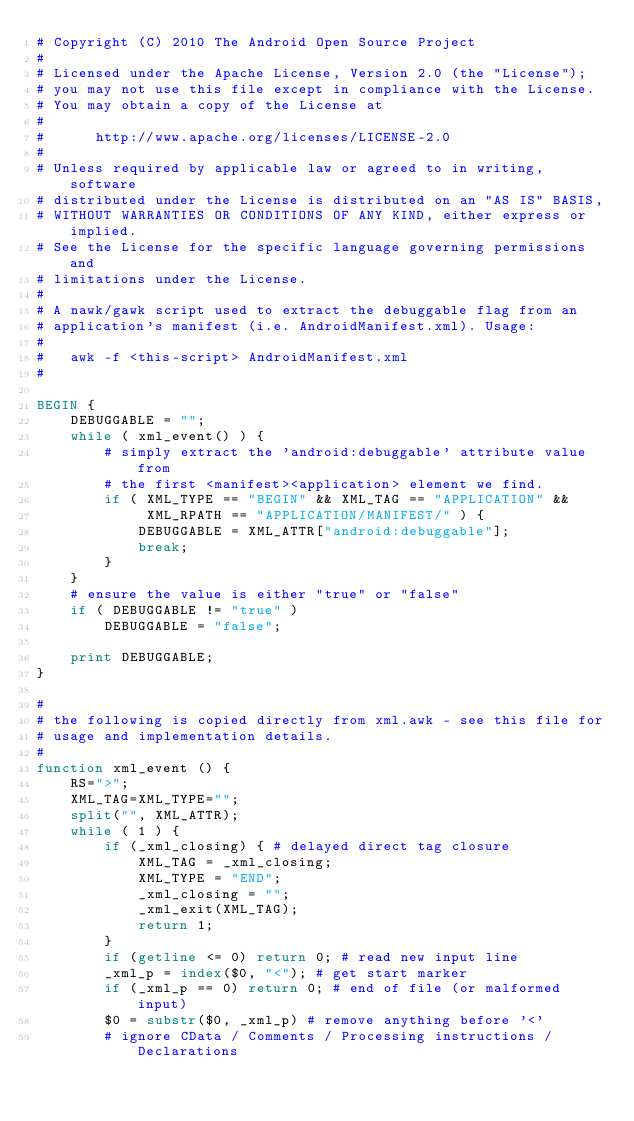Convert code to text. <code><loc_0><loc_0><loc_500><loc_500><_Awk_># Copyright (C) 2010 The Android Open Source Project
#
# Licensed under the Apache License, Version 2.0 (the "License");
# you may not use this file except in compliance with the License.
# You may obtain a copy of the License at
#
#      http://www.apache.org/licenses/LICENSE-2.0
#
# Unless required by applicable law or agreed to in writing, software
# distributed under the License is distributed on an "AS IS" BASIS,
# WITHOUT WARRANTIES OR CONDITIONS OF ANY KIND, either express or implied.
# See the License for the specific language governing permissions and
# limitations under the License.
#
# A nawk/gawk script used to extract the debuggable flag from an
# application's manifest (i.e. AndroidManifest.xml). Usage:
#
#   awk -f <this-script> AndroidManifest.xml
#

BEGIN {
    DEBUGGABLE = "";
    while ( xml_event() ) {
        # simply extract the 'android:debuggable' attribute value from
        # the first <manifest><application> element we find.
        if ( XML_TYPE == "BEGIN" && XML_TAG == "APPLICATION" &&
             XML_RPATH == "APPLICATION/MANIFEST/" ) {
            DEBUGGABLE = XML_ATTR["android:debuggable"];
            break;
        }
    }
    # ensure the value is either "true" or "false"
    if ( DEBUGGABLE != "true" )
        DEBUGGABLE = "false";

    print DEBUGGABLE;
}

#
# the following is copied directly from xml.awk - see this file for
# usage and implementation details.
#
function xml_event () {
    RS=">";
    XML_TAG=XML_TYPE="";
    split("", XML_ATTR);
    while ( 1 ) {
        if (_xml_closing) { # delayed direct tag closure
            XML_TAG = _xml_closing;
            XML_TYPE = "END";
            _xml_closing = "";
            _xml_exit(XML_TAG);
            return 1;
        }
        if (getline <= 0) return 0; # read new input line
        _xml_p = index($0, "<"); # get start marker
        if (_xml_p == 0) return 0; # end of file (or malformed input)
        $0 = substr($0, _xml_p) # remove anything before '<'
        # ignore CData / Comments / Processing instructions / Declarations</code> 